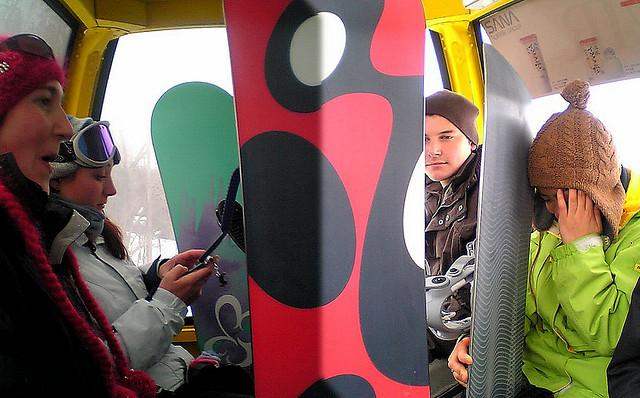What winter sport is this group participating in?

Choices:
A) snowboarding
B) skiing
C) sledding
D) ice skating snowboarding 